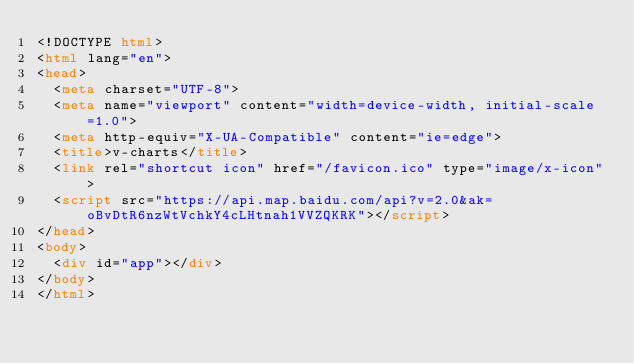Convert code to text. <code><loc_0><loc_0><loc_500><loc_500><_HTML_><!DOCTYPE html>
<html lang="en">
<head>
  <meta charset="UTF-8">
  <meta name="viewport" content="width=device-width, initial-scale=1.0">
  <meta http-equiv="X-UA-Compatible" content="ie=edge">
  <title>v-charts</title>
  <link rel="shortcut icon" href="/favicon.ico" type="image/x-icon">
  <script src="https://api.map.baidu.com/api?v=2.0&ak=oBvDtR6nzWtVchkY4cLHtnah1VVZQKRK"></script>
</head>
<body>
  <div id="app"></div>
</body>
</html>
</code> 